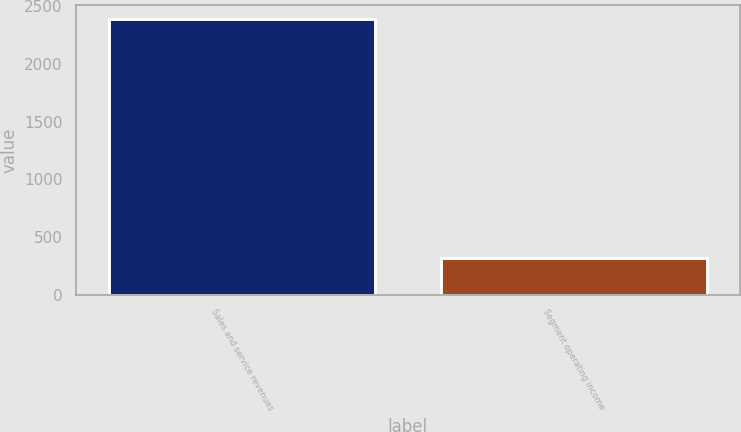Convert chart. <chart><loc_0><loc_0><loc_500><loc_500><bar_chart><fcel>Sales and service revenues<fcel>Segment operating income<nl><fcel>2389<fcel>321<nl></chart> 